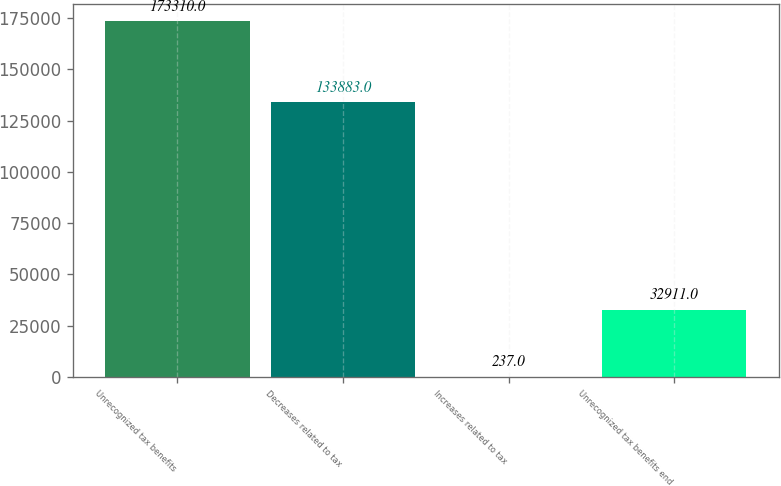Convert chart to OTSL. <chart><loc_0><loc_0><loc_500><loc_500><bar_chart><fcel>Unrecognized tax benefits<fcel>Decreases related to tax<fcel>Increases related to tax<fcel>Unrecognized tax benefits end<nl><fcel>173310<fcel>133883<fcel>237<fcel>32911<nl></chart> 